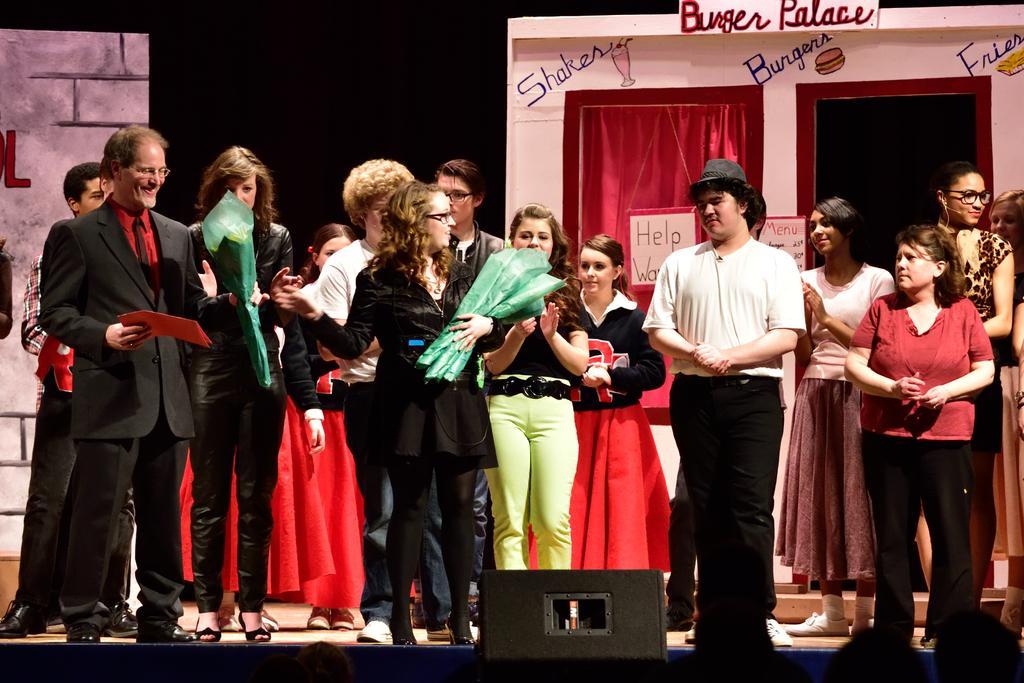How would you summarize this image in a sentence or two? In this image we can see a group of people standing on a stage and a few people are holding some objects. There is a dramatic setting behind a group of persons. 